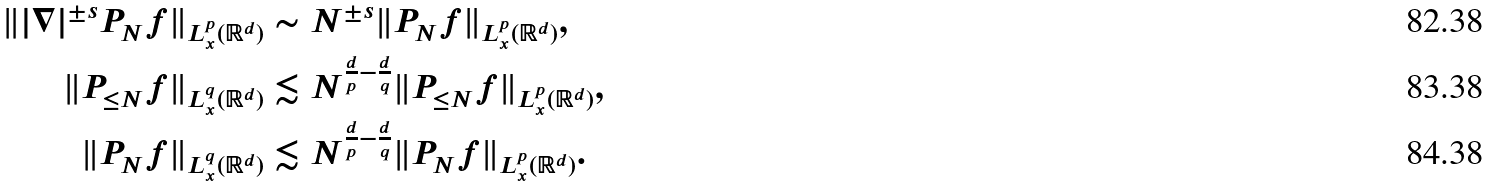<formula> <loc_0><loc_0><loc_500><loc_500>\| | \nabla | ^ { \pm s } P _ { N } f \| _ { L _ { x } ^ { p } ( \mathbb { R } ^ { d } ) } & \sim N ^ { \pm s } \| P _ { N } f \| _ { L _ { x } ^ { p } ( \mathbb { R } ^ { d } ) } , \\ \| P _ { \leq N } f \| _ { L _ { x } ^ { q } ( \mathbb { R } ^ { d } ) } & \lesssim N ^ { \frac { d } { p } - \frac { d } { q } } \| P _ { \leq N } f \| _ { L _ { x } ^ { p } ( \mathbb { R } ^ { d } ) } , \\ \| P _ { N } f \| _ { L _ { x } ^ { q } ( \mathbb { R } ^ { d } ) } & \lesssim N ^ { \frac { d } { p } - \frac { d } { q } } \| P _ { N } f \| _ { L _ { x } ^ { p } ( \mathbb { R } ^ { d } ) } .</formula> 